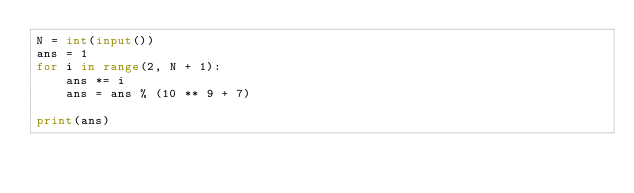<code> <loc_0><loc_0><loc_500><loc_500><_Python_>N = int(input())
ans = 1
for i in range(2, N + 1):
    ans *= i
    ans = ans % (10 ** 9 + 7)

print(ans)</code> 